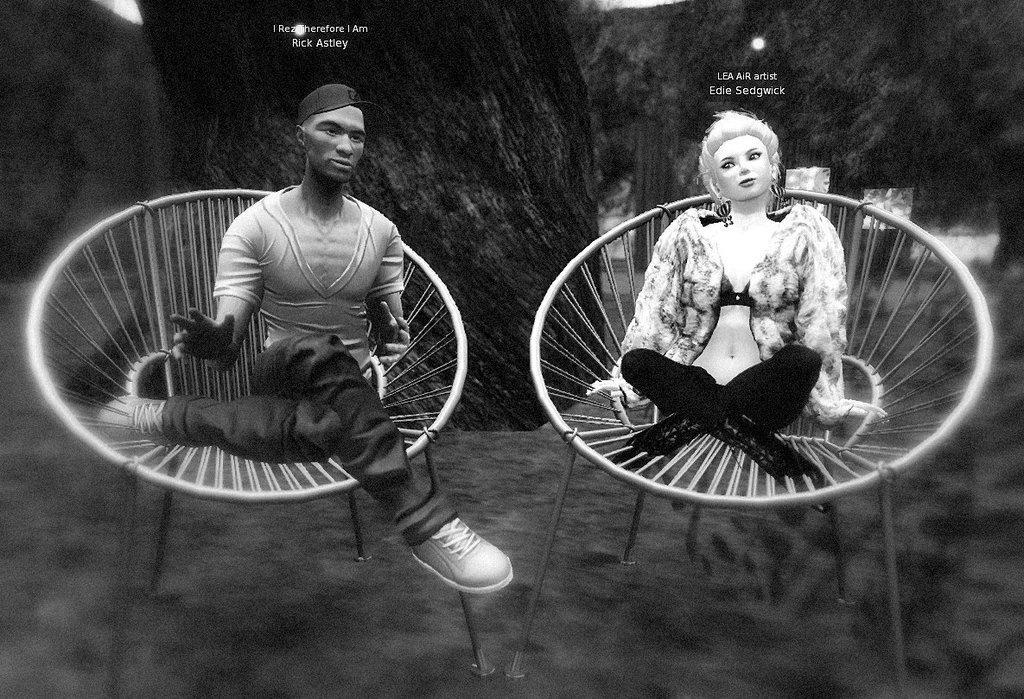Please provide a concise description of this image. In this image there are two statues sitting on chairs. In the background there are trees. In the left the statue is of a man wearing cap. In the right the statue is of a woman wearing jacket. 